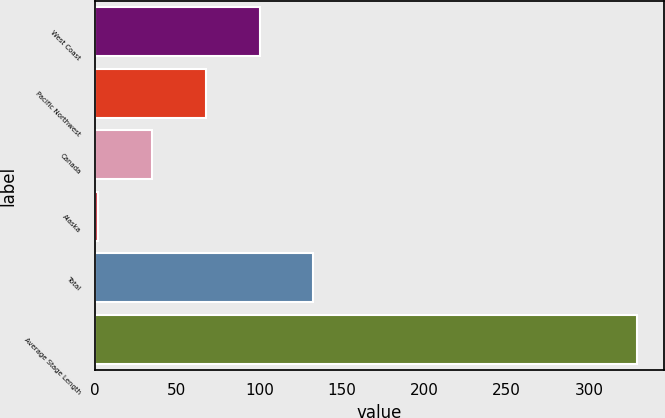Convert chart. <chart><loc_0><loc_0><loc_500><loc_500><bar_chart><fcel>West Coast<fcel>Pacific Northwest<fcel>Canada<fcel>Alaska<fcel>Total<fcel>Average Stage Length<nl><fcel>100.1<fcel>67.4<fcel>34.7<fcel>2<fcel>132.8<fcel>329<nl></chart> 